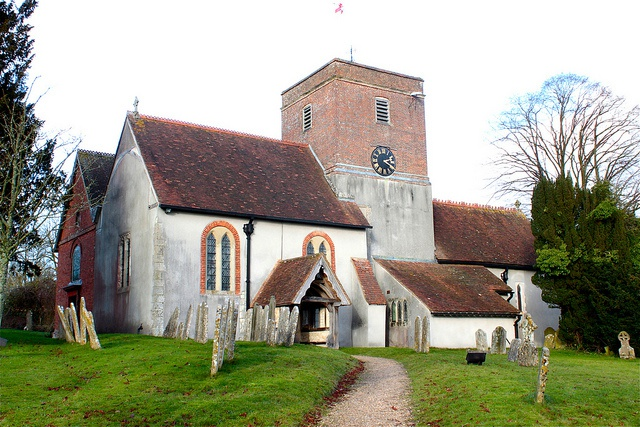Describe the objects in this image and their specific colors. I can see a clock in white, gray, blue, darkgray, and navy tones in this image. 